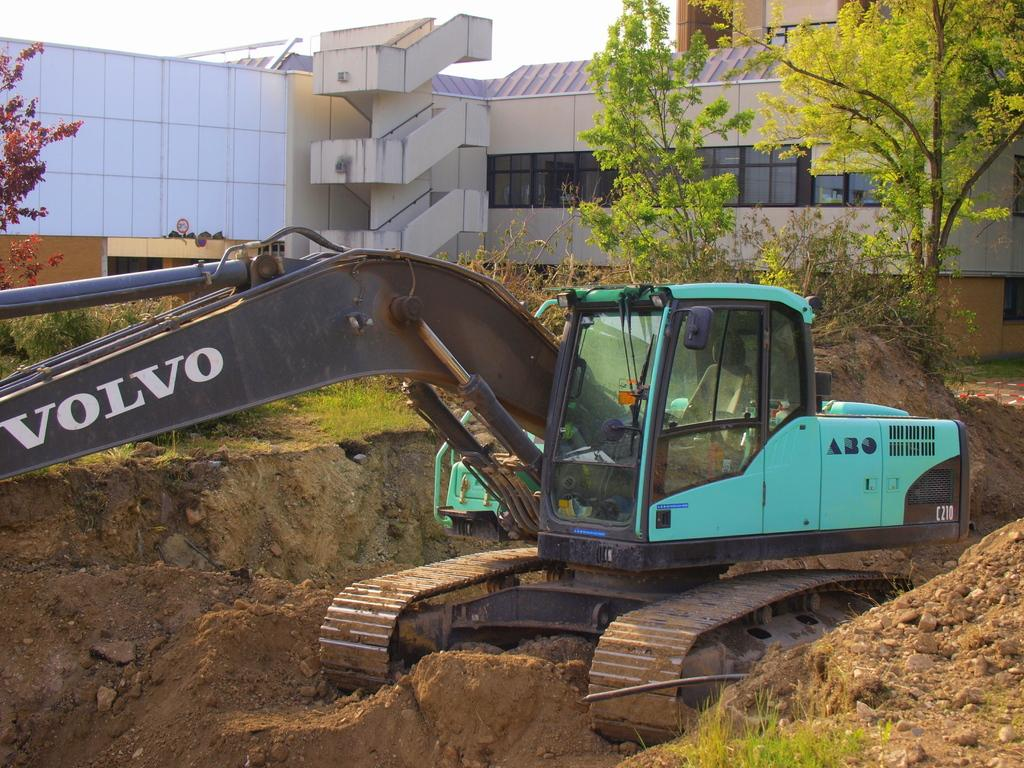What type of machinery is present in the image? There is a crane in the image. What color is the crane? The crane is blue. What type of terrain is visible in the image? There is mud visible in the image. What type of vegetation is present in the image? There are trees in the image. What can be seen in the background of the image? There is a building and the sky visible in the background of the image. What type of cheese is being requested by the crane in the image? There is no cheese or request present in the image; it features a blue crane, mud, trees, a building, and the sky. 